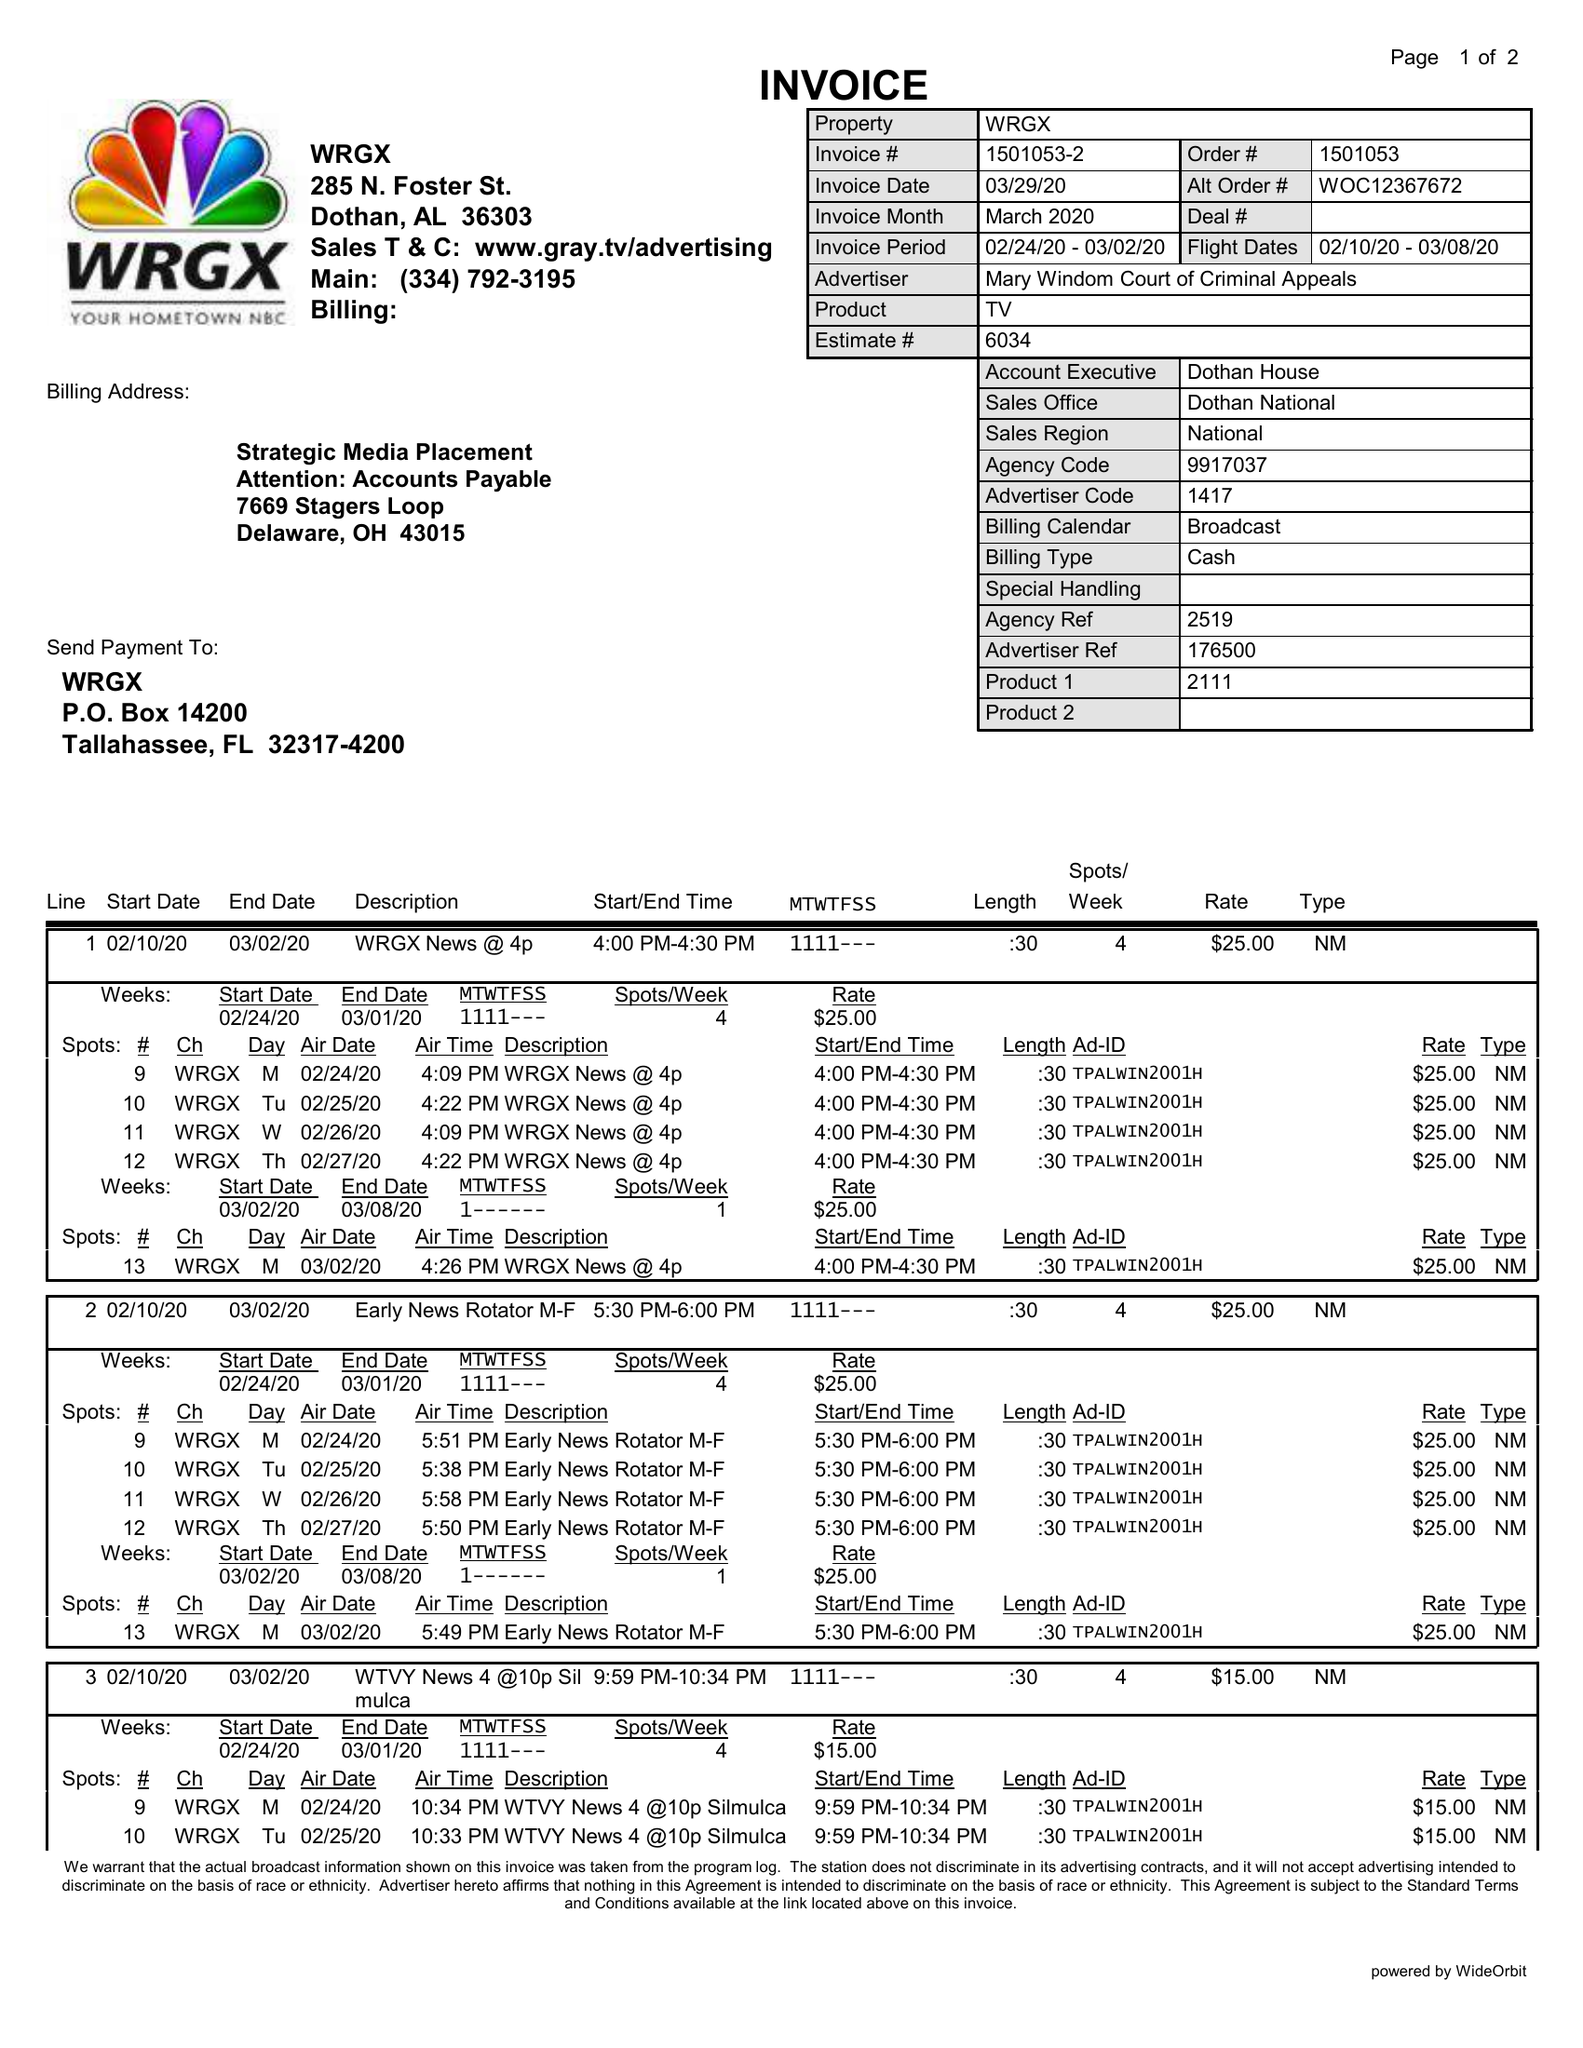What is the value for the advertiser?
Answer the question using a single word or phrase. MARY WINDOM COURT OF CRIMINAL APPEALS 